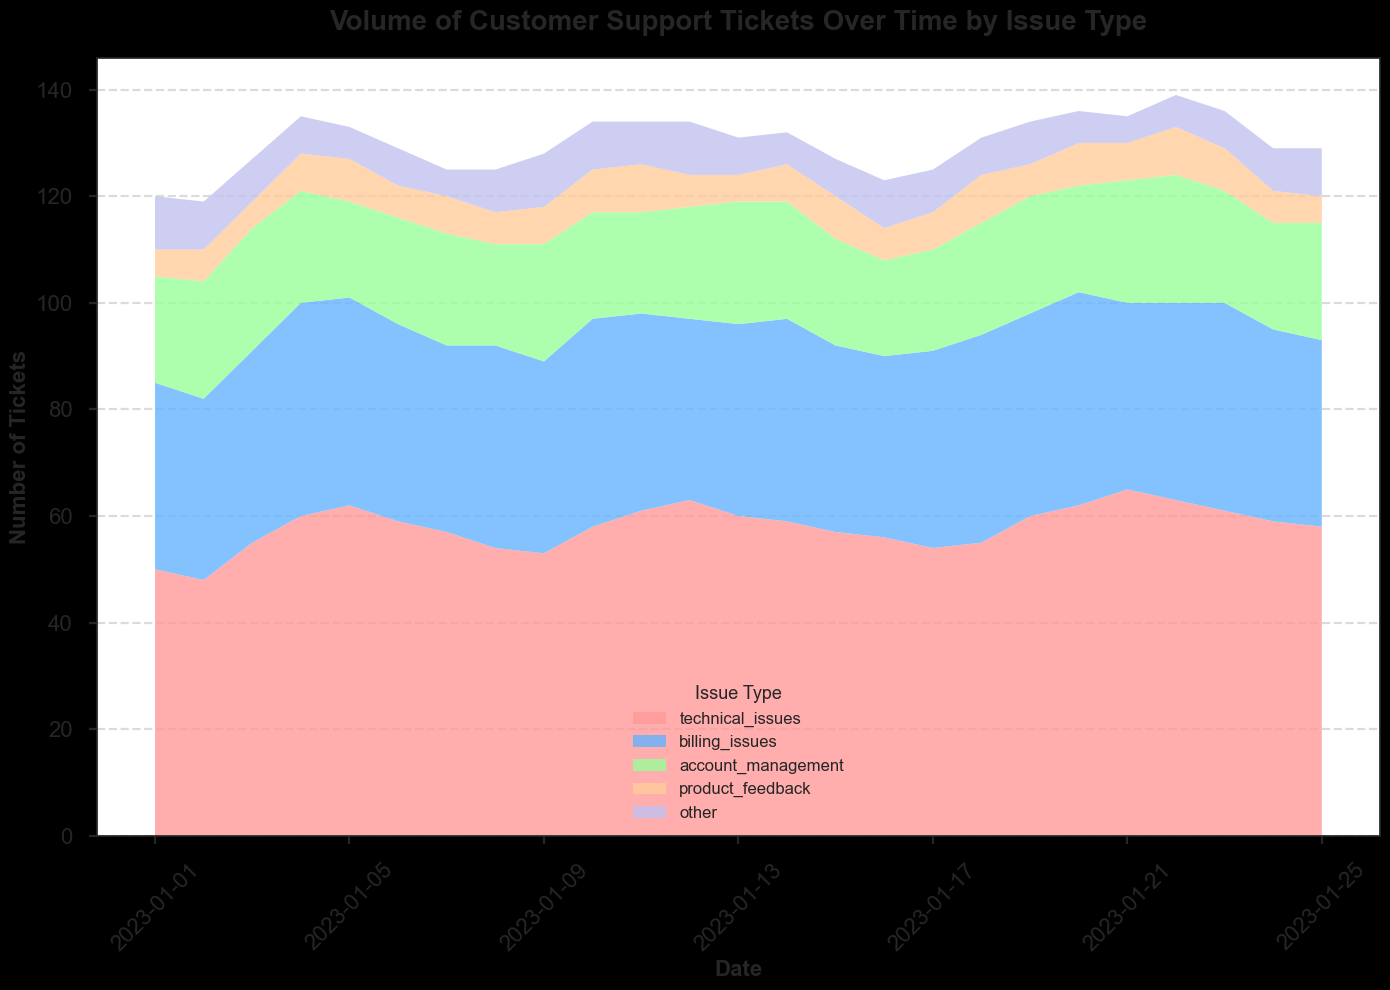Which issue type had the highest number of customer support tickets on January 10, 2023? Looking at January 10, 2023, in the area chart, the height of the colored segments indicates the number of tickets for each issue type. The segment representing technical issues is the highest.
Answer: Technical issues During which date range did billing issues have a relatively stable number of tickets around 37 to 39? By observing the color associated with billing issues, the height of this segment looks relatively stable between 37 to 39 tickets from January 6, 2023, to January 14, 2023, with minor fluctuations.
Answer: January 6, 2023, to January 14, 2023 On January 21, 2023, approximately how many total tickets were there, and what percentage of these were technical issues? Sum the heights of all the segments on January 21, 2023: technical issues (65) + billing issues (35) + account management (23) + product feedback (7) + other (5) = 135 tickets in total. Technical issues account for 65/135 * 100 = 48.15%.
Answer: 135 tickets total, 48.15% technical issues How did the number of product feedback tickets change from January 5, 2023, to January 25, 2023? On January 5, there were 8 product feedback tickets. On January 25, there were 5 tickets. The change is a decrease of 8 - 5 = 3 tickets.
Answer: Decreased by 3 tickets Which issue type had the least variability in the number of support tickets over the period shown? Observing the consistency of the height of each colored segment, the segment for product feedback shows the least fluctuation, indicating the least variability in the number of tickets.
Answer: Product feedback What is the difference in the number of technical issues between the highest and lowest day? The highest number of technical issues is 65 (on January 21), and the lowest is 48 (on January 2). The difference is 65 - 48 = 17 tickets.
Answer: 17 tickets If the goal is to reduce account management issues by 20% from their highest value observed, what is the new target number? The highest value for account management issues is 24 tickets (on January 22). A 20% reduction means 24 * 0.8 = 19.2, rounded to the nearest whole number is 19 tickets.
Answer: 19 tickets Between January 10 and January 15, did the number of 'other' issue tickets increase, decrease, or remain the same? On January 10, the number of 'other' issue tickets is 9. By January 15, the number decreases to 7. Hence, it decreased.
Answer: Decreased 